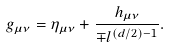Convert formula to latex. <formula><loc_0><loc_0><loc_500><loc_500>g _ { \mu \nu } & = \eta _ { \mu \nu } + \frac { h _ { \mu \nu } } { \mp l ^ { ( d / 2 ) - 1 } } .</formula> 